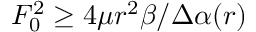Convert formula to latex. <formula><loc_0><loc_0><loc_500><loc_500>F _ { 0 } ^ { 2 } \geq 4 \mu r ^ { 2 } \beta / \Delta \alpha ( r )</formula> 